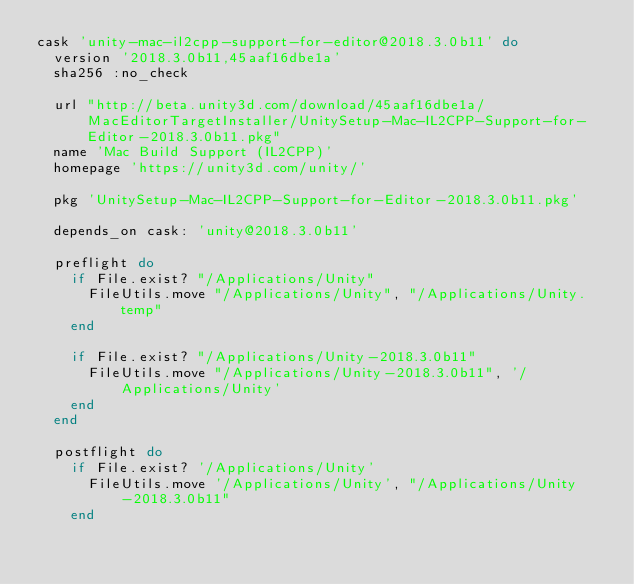<code> <loc_0><loc_0><loc_500><loc_500><_Ruby_>cask 'unity-mac-il2cpp-support-for-editor@2018.3.0b11' do
  version '2018.3.0b11,45aaf16dbe1a'
  sha256 :no_check

  url "http://beta.unity3d.com/download/45aaf16dbe1a/MacEditorTargetInstaller/UnitySetup-Mac-IL2CPP-Support-for-Editor-2018.3.0b11.pkg"
  name 'Mac Build Support (IL2CPP)'
  homepage 'https://unity3d.com/unity/'

  pkg 'UnitySetup-Mac-IL2CPP-Support-for-Editor-2018.3.0b11.pkg'

  depends_on cask: 'unity@2018.3.0b11'

  preflight do
    if File.exist? "/Applications/Unity"
      FileUtils.move "/Applications/Unity", "/Applications/Unity.temp"
    end

    if File.exist? "/Applications/Unity-2018.3.0b11"
      FileUtils.move "/Applications/Unity-2018.3.0b11", '/Applications/Unity'
    end
  end

  postflight do
    if File.exist? '/Applications/Unity'
      FileUtils.move '/Applications/Unity', "/Applications/Unity-2018.3.0b11"
    end
</code> 